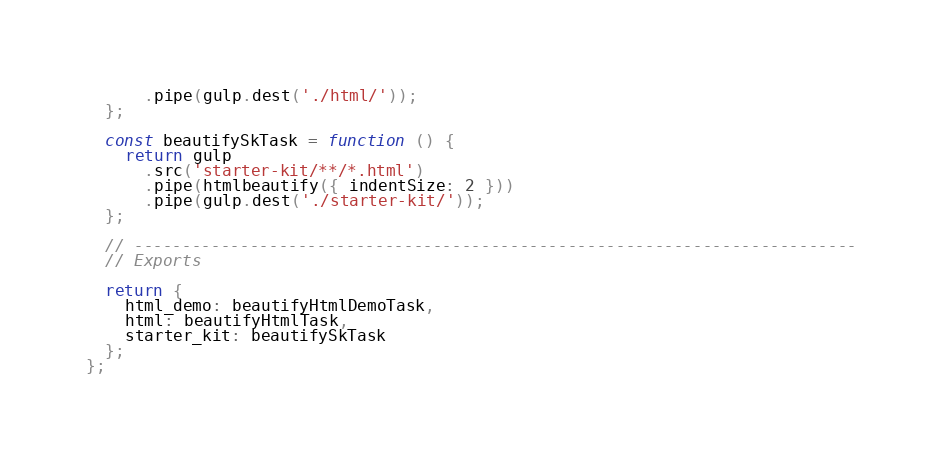Convert code to text. <code><loc_0><loc_0><loc_500><loc_500><_JavaScript_>      .pipe(gulp.dest('./html/'));
  };

  const beautifySkTask = function () {
    return gulp
      .src('starter-kit/**/*.html')
      .pipe(htmlbeautify({ indentSize: 2 }))
      .pipe(gulp.dest('./starter-kit/'));
  };

  // ---------------------------------------------------------------------------
  // Exports

  return {
    html_demo: beautifyHtmlDemoTask,
    html: beautifyHtmlTask,
    starter_kit: beautifySkTask
  };
};
</code> 